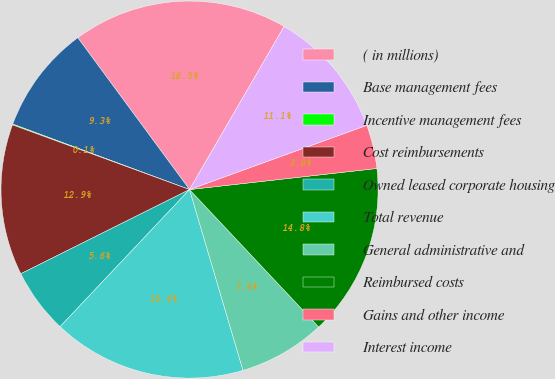Convert chart. <chart><loc_0><loc_0><loc_500><loc_500><pie_chart><fcel>( in millions)<fcel>Base management fees<fcel>Incentive management fees<fcel>Cost reimbursements<fcel>Owned leased corporate housing<fcel>Total revenue<fcel>General administrative and<fcel>Reimbursed costs<fcel>Gains and other income<fcel>Interest income<nl><fcel>18.46%<fcel>9.26%<fcel>0.07%<fcel>12.94%<fcel>5.59%<fcel>16.62%<fcel>7.43%<fcel>14.78%<fcel>3.75%<fcel>11.1%<nl></chart> 